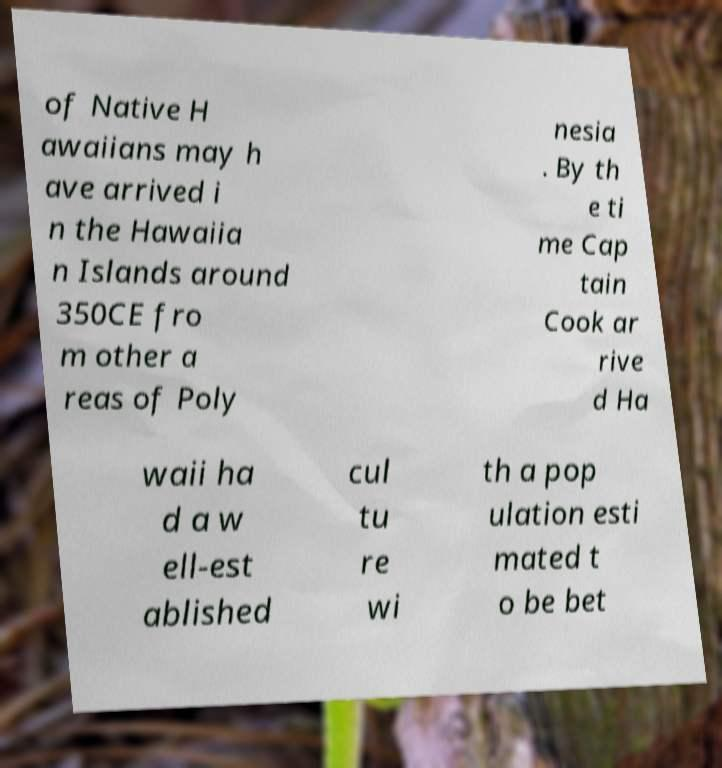What messages or text are displayed in this image? I need them in a readable, typed format. of Native H awaiians may h ave arrived i n the Hawaiia n Islands around 350CE fro m other a reas of Poly nesia . By th e ti me Cap tain Cook ar rive d Ha waii ha d a w ell-est ablished cul tu re wi th a pop ulation esti mated t o be bet 